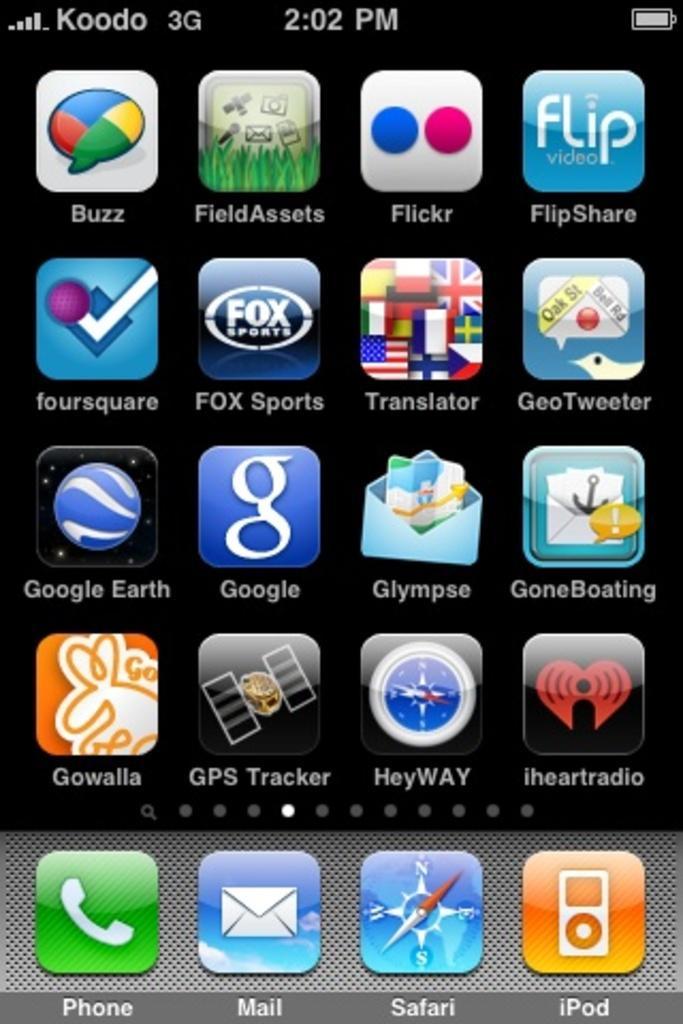In one or two sentences, can you explain what this image depicts? In this image I see the phone screen on which there are number of apps and words written and I see the numbers over here and I see it is black in the background. 